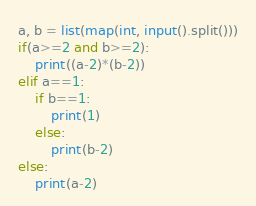<code> <loc_0><loc_0><loc_500><loc_500><_Python_>a, b = list(map(int, input().split()))
if(a>=2 and b>=2):
    print((a-2)*(b-2))
elif a==1:
    if b==1:
        print(1)
    else:
        print(b-2)
else:
    print(a-2)</code> 